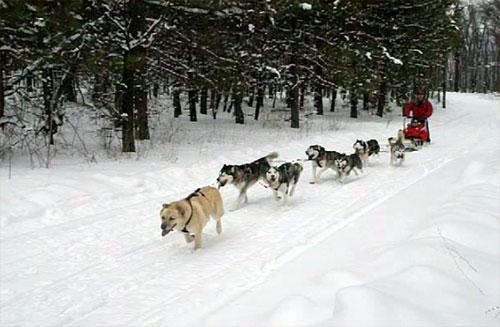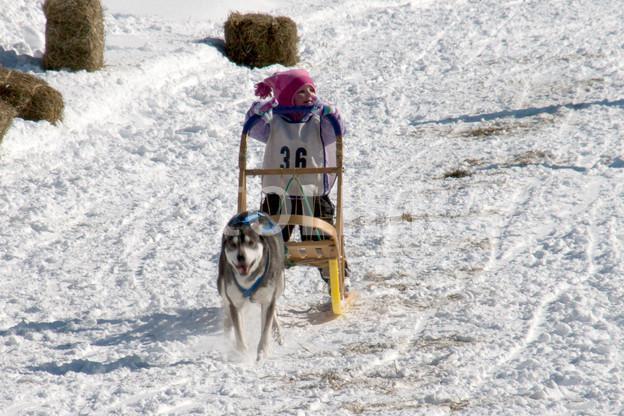The first image is the image on the left, the second image is the image on the right. Assess this claim about the two images: "sled dogs are pulling a wagon on a dirt road". Correct or not? Answer yes or no. No. The first image is the image on the left, the second image is the image on the right. For the images shown, is this caption "A team of sled dogs is walking on a road that has no snow on it." true? Answer yes or no. No. 